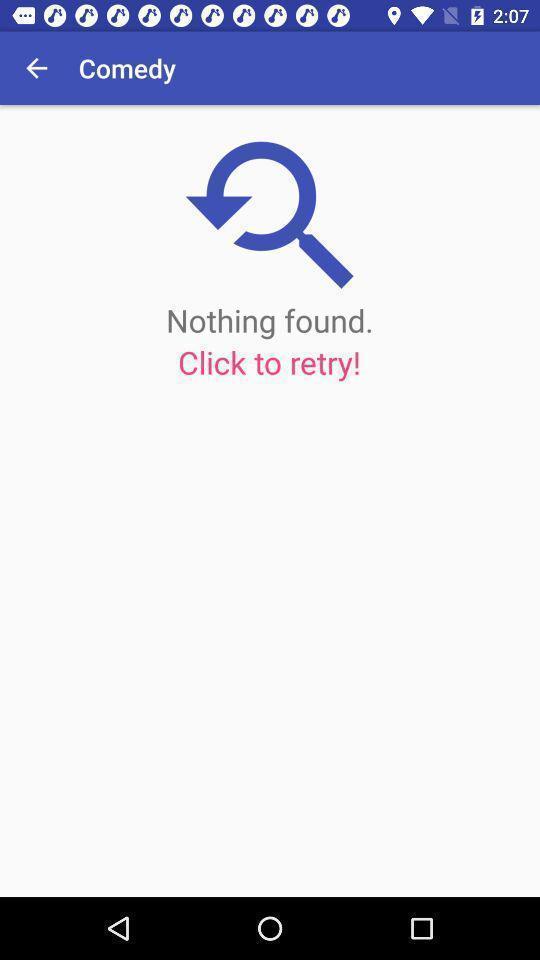Tell me about the visual elements in this screen capture. Page displaying no results and retry option. 